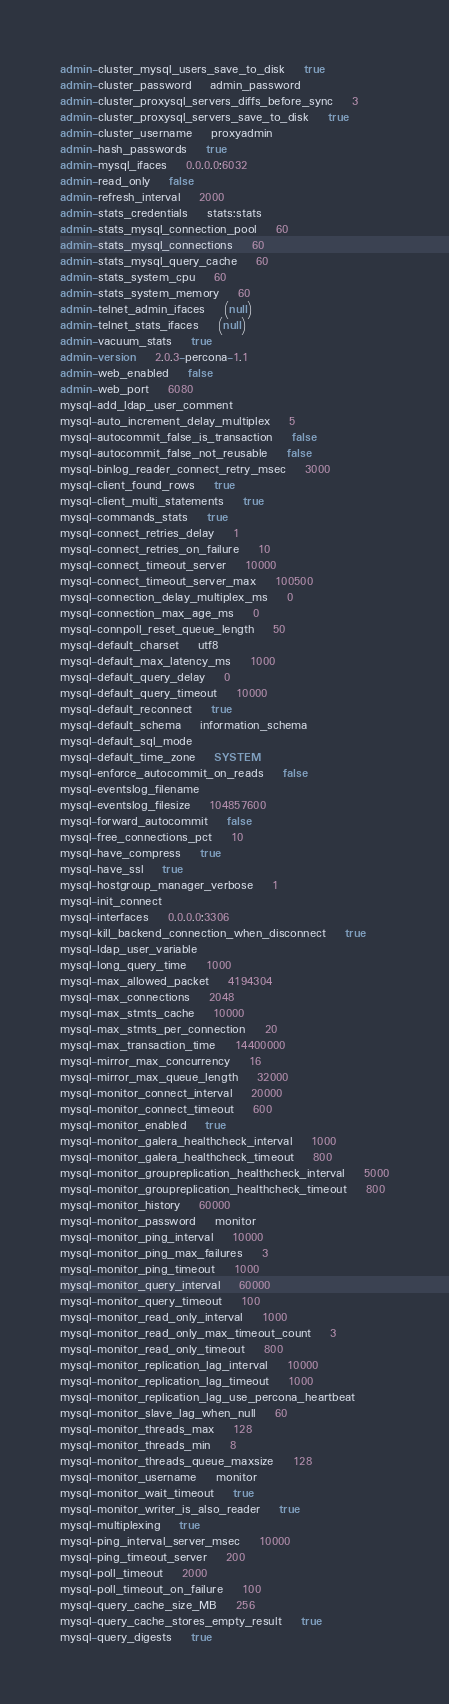<code> <loc_0><loc_0><loc_500><loc_500><_SQL_>admin-cluster_mysql_users_save_to_disk	true
admin-cluster_password	admin_password
admin-cluster_proxysql_servers_diffs_before_sync	3
admin-cluster_proxysql_servers_save_to_disk	true
admin-cluster_username	proxyadmin
admin-hash_passwords	true
admin-mysql_ifaces	0.0.0.0:6032
admin-read_only	false
admin-refresh_interval	2000
admin-stats_credentials	stats:stats
admin-stats_mysql_connection_pool	60
admin-stats_mysql_connections	60
admin-stats_mysql_query_cache	60
admin-stats_system_cpu	60
admin-stats_system_memory	60
admin-telnet_admin_ifaces	(null)
admin-telnet_stats_ifaces	(null)
admin-vacuum_stats	true
admin-version	2.0.3-percona-1.1
admin-web_enabled	false
admin-web_port	6080
mysql-add_ldap_user_comment	
mysql-auto_increment_delay_multiplex	5
mysql-autocommit_false_is_transaction	false
mysql-autocommit_false_not_reusable	false
mysql-binlog_reader_connect_retry_msec	3000
mysql-client_found_rows	true
mysql-client_multi_statements	true
mysql-commands_stats	true
mysql-connect_retries_delay	1
mysql-connect_retries_on_failure	10
mysql-connect_timeout_server	10000
mysql-connect_timeout_server_max	100500
mysql-connection_delay_multiplex_ms	0
mysql-connection_max_age_ms	0
mysql-connpoll_reset_queue_length	50
mysql-default_charset	utf8
mysql-default_max_latency_ms	1000
mysql-default_query_delay	0
mysql-default_query_timeout	10000
mysql-default_reconnect	true
mysql-default_schema	information_schema
mysql-default_sql_mode	
mysql-default_time_zone	SYSTEM
mysql-enforce_autocommit_on_reads	false
mysql-eventslog_filename	
mysql-eventslog_filesize	104857600
mysql-forward_autocommit	false
mysql-free_connections_pct	10
mysql-have_compress	true
mysql-have_ssl	true
mysql-hostgroup_manager_verbose	1
mysql-init_connect	
mysql-interfaces	0.0.0.0:3306
mysql-kill_backend_connection_when_disconnect	true
mysql-ldap_user_variable	
mysql-long_query_time	1000
mysql-max_allowed_packet	4194304
mysql-max_connections	2048
mysql-max_stmts_cache	10000
mysql-max_stmts_per_connection	20
mysql-max_transaction_time	14400000
mysql-mirror_max_concurrency	16
mysql-mirror_max_queue_length	32000
mysql-monitor_connect_interval	20000
mysql-monitor_connect_timeout	600
mysql-monitor_enabled	true
mysql-monitor_galera_healthcheck_interval	1000
mysql-monitor_galera_healthcheck_timeout	800
mysql-monitor_groupreplication_healthcheck_interval	5000
mysql-monitor_groupreplication_healthcheck_timeout	800
mysql-monitor_history	60000
mysql-monitor_password	monitor
mysql-monitor_ping_interval	10000
mysql-monitor_ping_max_failures	3
mysql-monitor_ping_timeout	1000
mysql-monitor_query_interval	60000
mysql-monitor_query_timeout	100
mysql-monitor_read_only_interval	1000
mysql-monitor_read_only_max_timeout_count	3
mysql-monitor_read_only_timeout	800
mysql-monitor_replication_lag_interval	10000
mysql-monitor_replication_lag_timeout	1000
mysql-monitor_replication_lag_use_percona_heartbeat	
mysql-monitor_slave_lag_when_null	60
mysql-monitor_threads_max	128
mysql-monitor_threads_min	8
mysql-monitor_threads_queue_maxsize	128
mysql-monitor_username	monitor
mysql-monitor_wait_timeout	true
mysql-monitor_writer_is_also_reader	true
mysql-multiplexing	true
mysql-ping_interval_server_msec	10000
mysql-ping_timeout_server	200
mysql-poll_timeout	2000
mysql-poll_timeout_on_failure	100
mysql-query_cache_size_MB	256
mysql-query_cache_stores_empty_result	true
mysql-query_digests	true</code> 